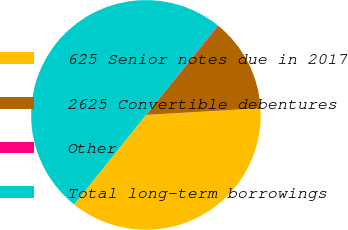<chart> <loc_0><loc_0><loc_500><loc_500><pie_chart><fcel>625 Senior notes due in 2017<fcel>2625 Convertible debentures<fcel>Other<fcel>Total long-term borrowings<nl><fcel>36.69%<fcel>13.2%<fcel>0.11%<fcel>50.0%<nl></chart> 